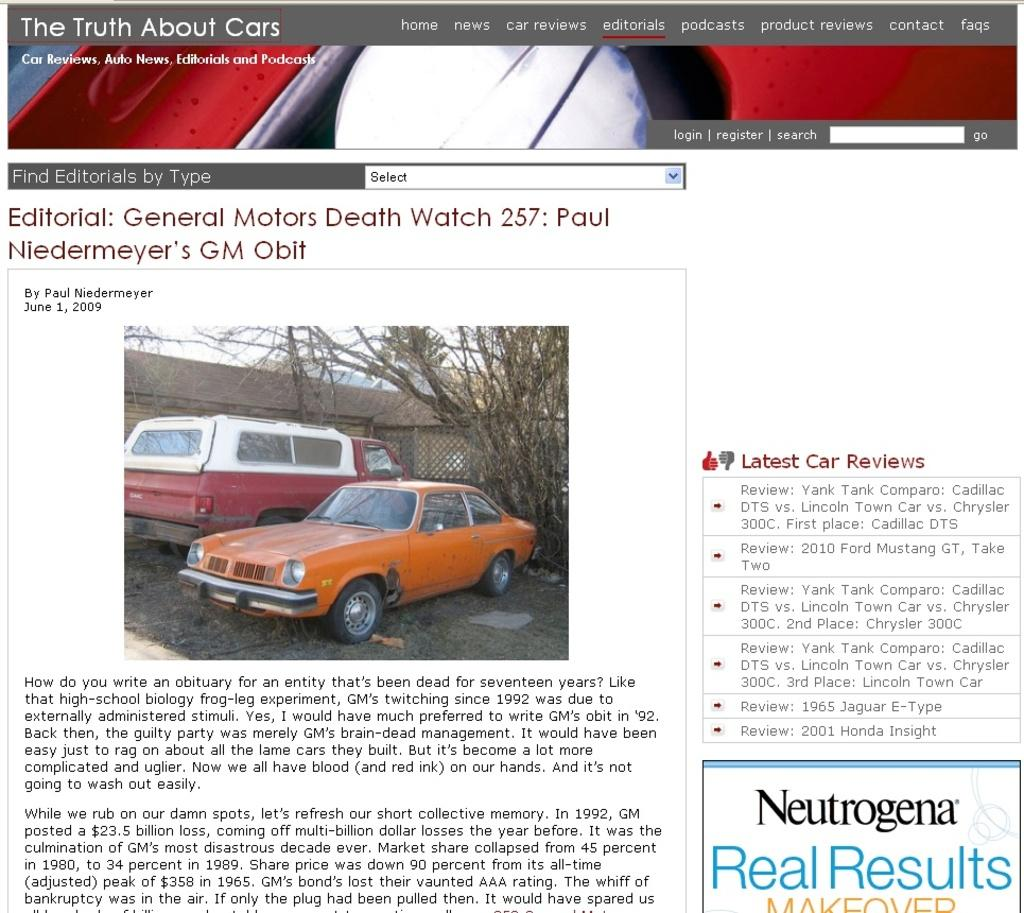What is the main visual element in the advertisement? The advertisement contains a picture. What types of objects are included in the picture? The picture includes vehicles, trees, and a shed. Where is the text located in the advertisement? The text is written at the bottom of the advertisement. What type of frame is used to display the hour in the advertisement? There is no frame or hour displayed in the advertisement; it contains a picture with text at the bottom. How much salt is visible in the advertisement? There is no salt present in the advertisement. 